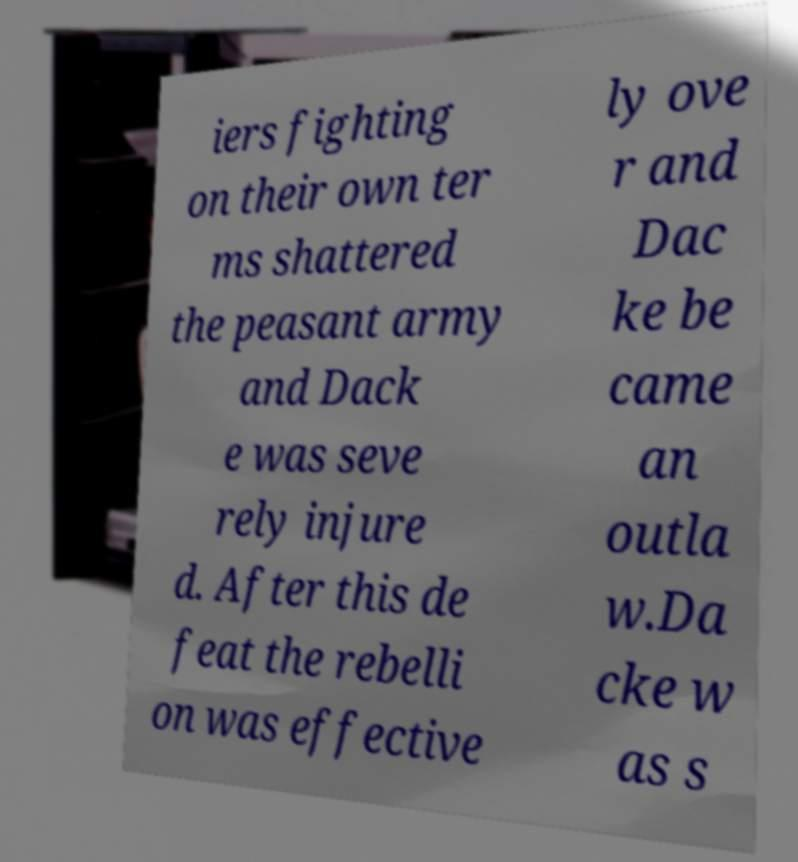Could you assist in decoding the text presented in this image and type it out clearly? iers fighting on their own ter ms shattered the peasant army and Dack e was seve rely injure d. After this de feat the rebelli on was effective ly ove r and Dac ke be came an outla w.Da cke w as s 